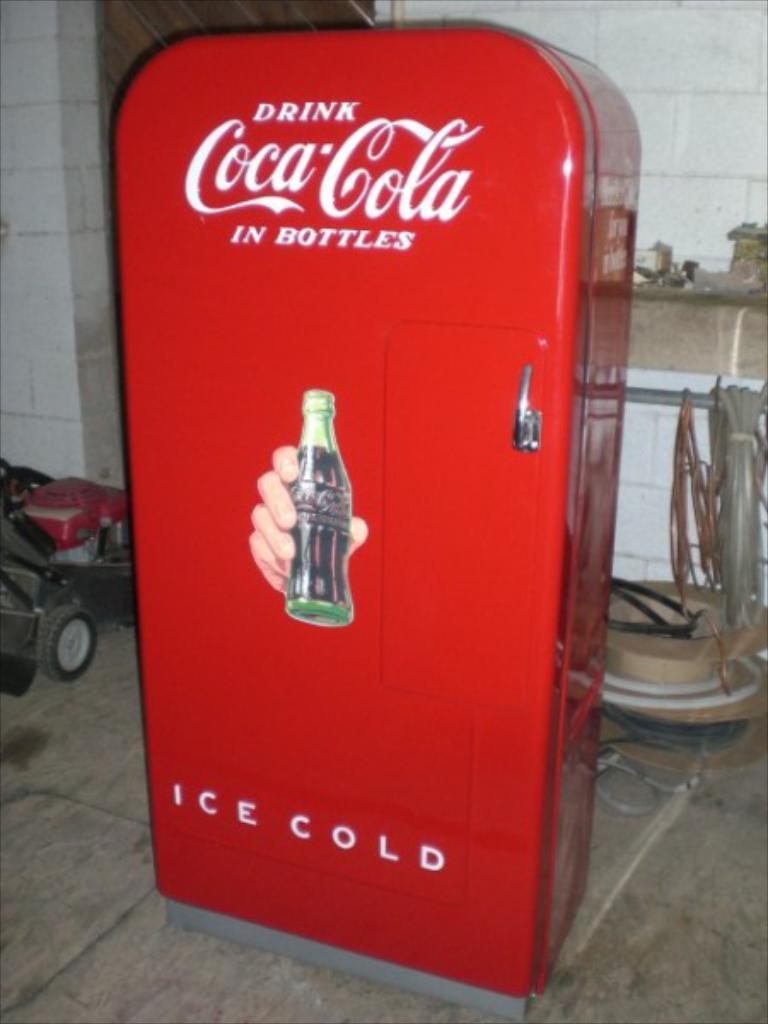In one or two sentences, can you explain what this image depicts? In the image there is a soft drink vending machine, behind it there is a wooden table and on the left side there is a garden cutting machine. 